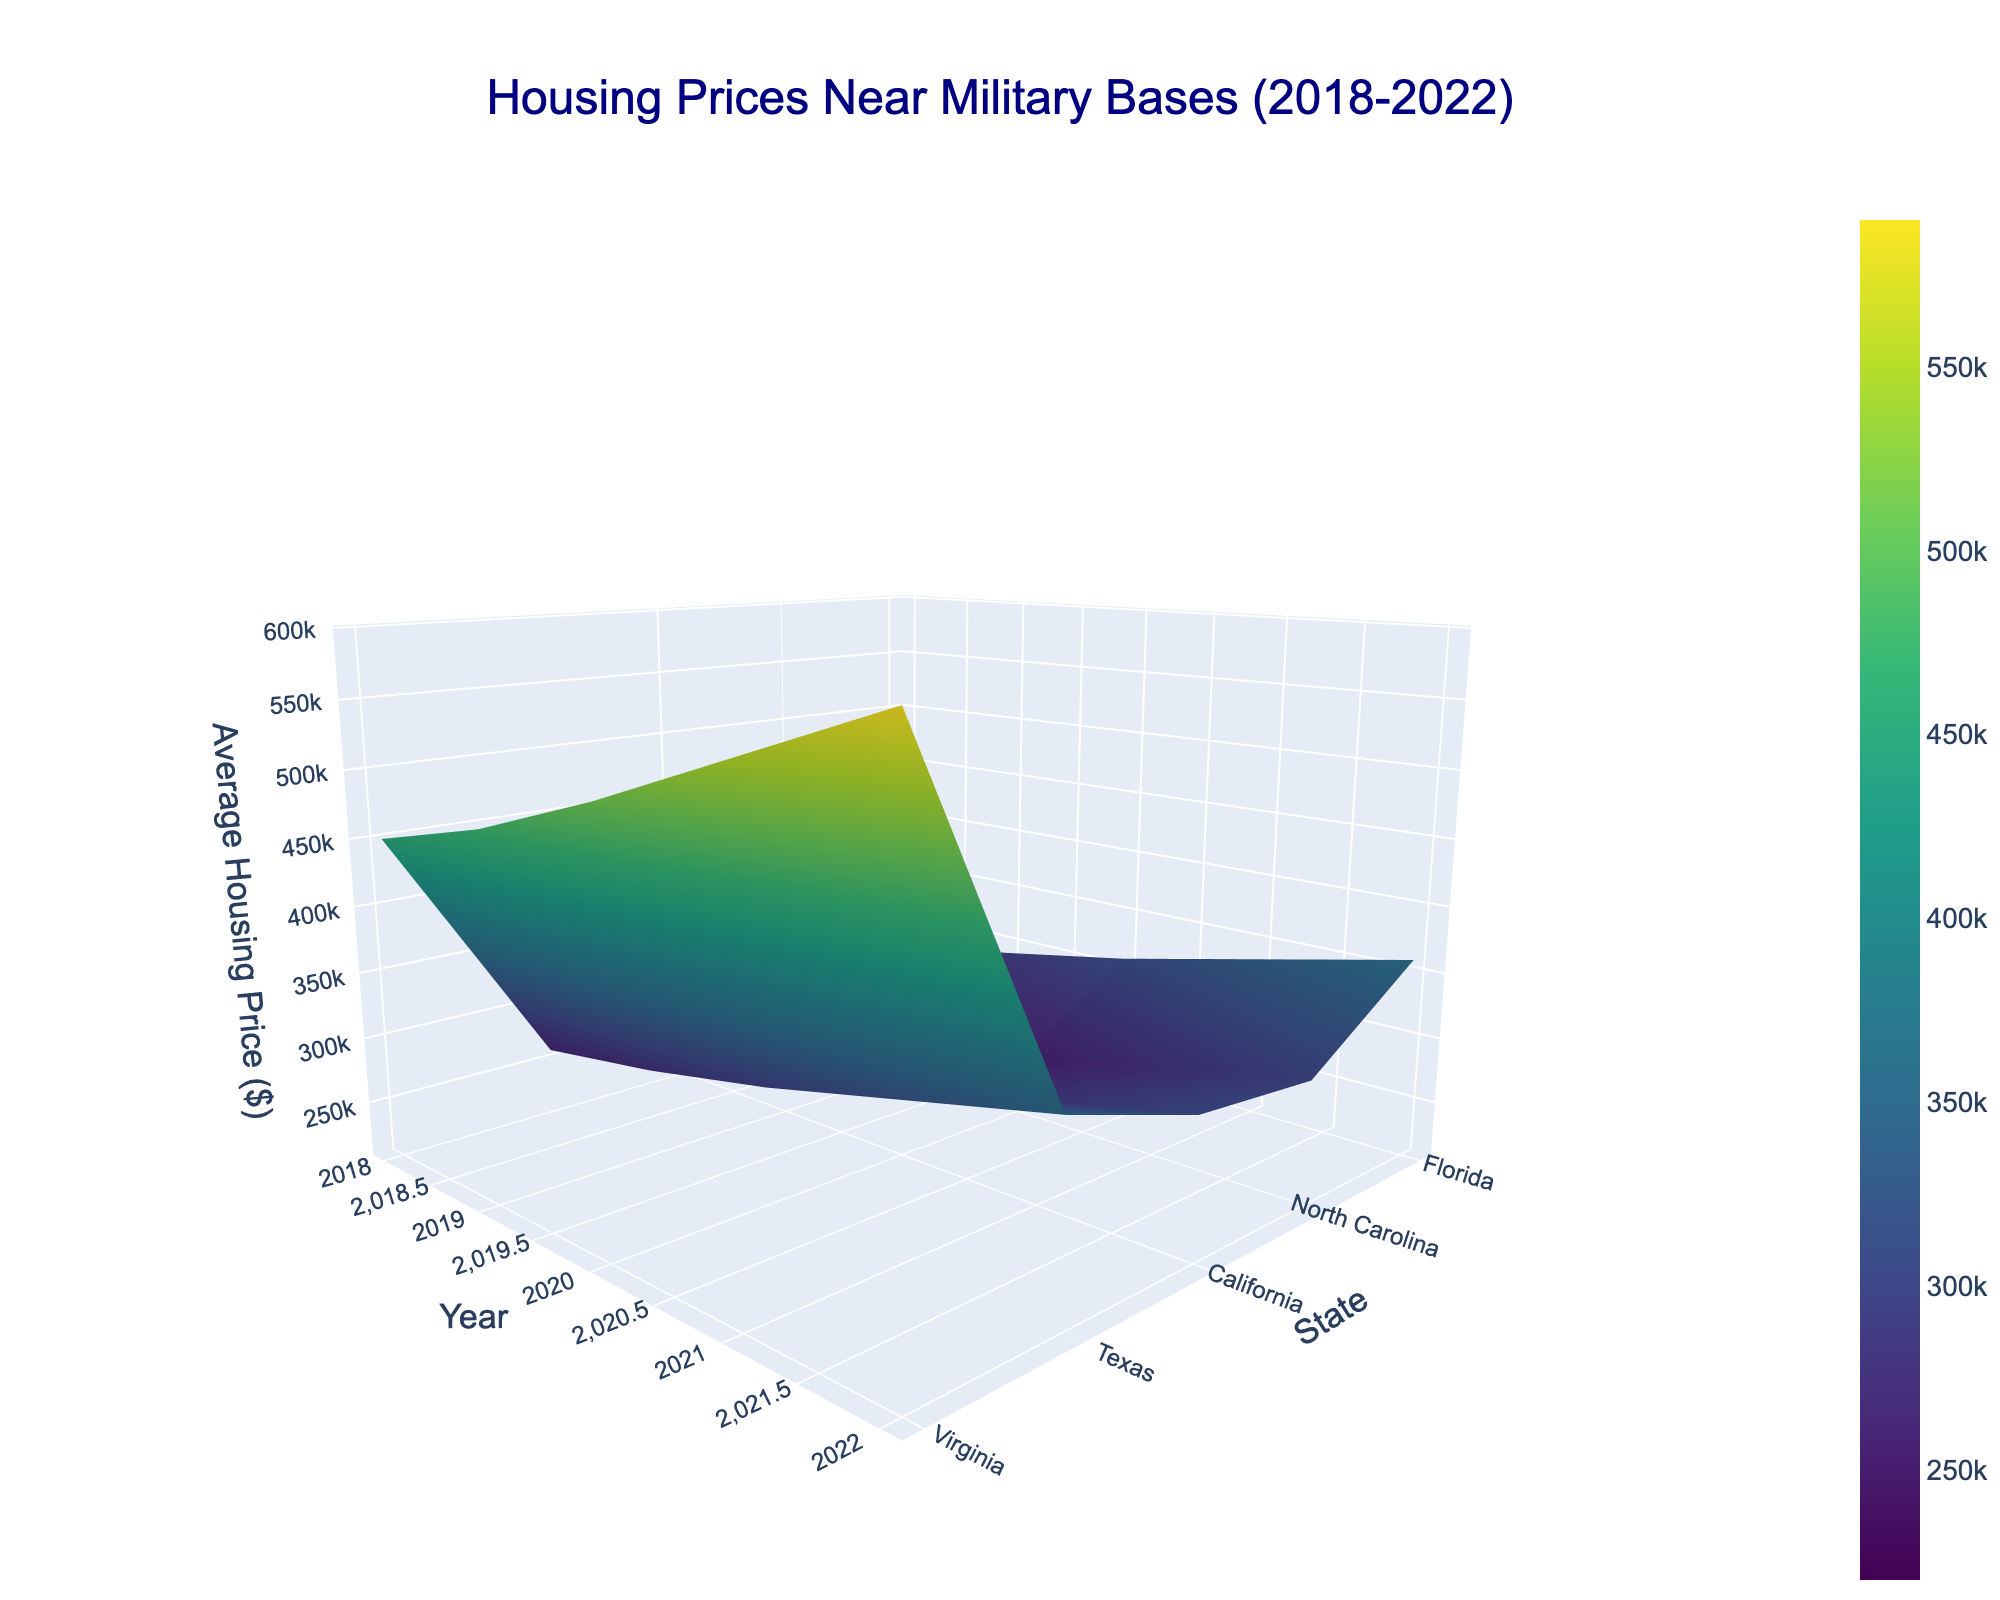What is the title of the plot? The title can be seen at the top of the figure. It reads "Housing Prices Near Military Bases (2018-2022)".
Answer: Housing Prices Near Military Bases (2018-2022) Which state had the highest average housing prices in 2020? Observe the plot and identify the peak in the Z-axis for the year 2020. The highest point is found over California.
Answer: California How did the housing prices in Texas change from 2018 to 2022? Look at the surface plot along the Texas line on the Y-axis from 2018 to 2022. Prices increase steadily each year, reaching a peak in 2022.
Answer: Increased What is the approximate difference in average housing prices between Virginia and North Carolina in 2022? Check the Z-values corresponding to Virginia and North Carolina for the year 2022. Virginia is around $360,000 and North Carolina about $310,000. The difference is $360,000 - $310,000 = $50,000.
Answer: $50,000 Which state had the most significant increase in housing prices from 2018 to 2022? Compare the height difference (Z-values) of each state between 2018 and 2022. California shows the most significant increase.
Answer: California In which year did Florida reach an average housing price of approximately $320,000? Locate the Florida line on the Y-axis and see where the surface intersects near $320,000 on the Z-axis. It intersects in the year 2021.
Answer: 2021 Compare the housing prices trends in Virginia and Texas. Which state had a sharper increase? Examine the incline of the surface plot lines for both Virginia and Texas from 2018 to 2022. Virginia shows a steeper incline compared to Texas.
Answer: Virginia If you're looking for the most affordable housing state in 2022, which state should you consider? Evaluate the Z-values for all states in 2022. Texas, showing the lowest Z-value, is the most affordable.
Answer: Texas What pattern do you notice in the housing prices across all states from 2018 to 2022? Observe the general direction of the surface plot. Across all states, there is a consistent increase in housing prices from 2018 to 2022.
Answer: Consistent increase By how much did the average housing price in California increase from 2018 to 2020? Check the Z-values for California for 2018 and 2020. The prices were $450,000 in 2018 and increased to $510,000 in 2020. The difference is $510,000 - $450,000 = $60,000.
Answer: $60,000 